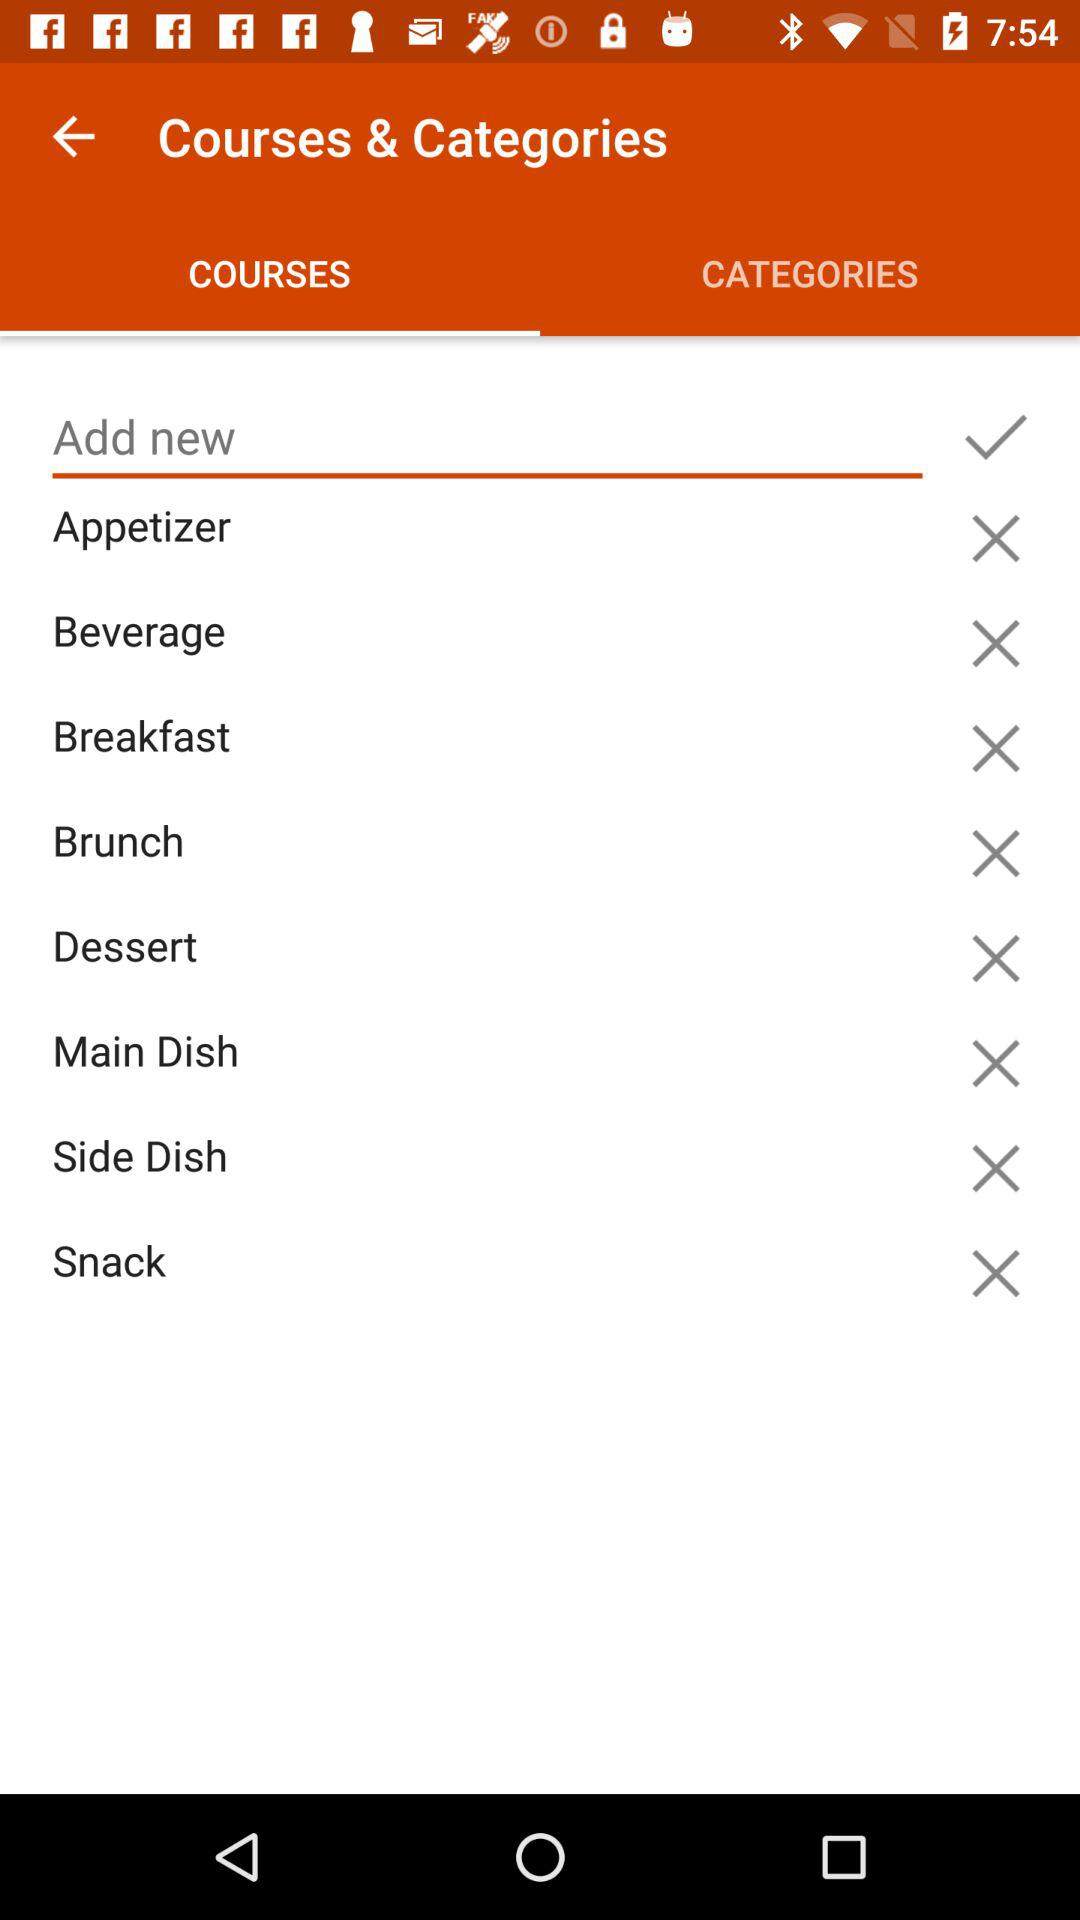Which tab is selected? The selected tab is courses. 